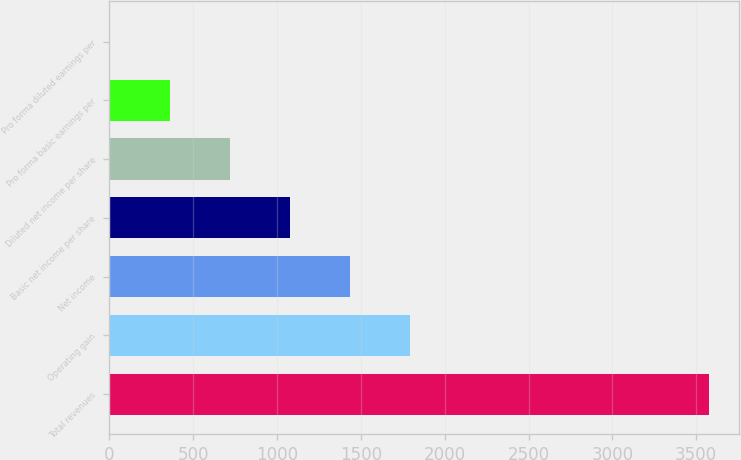Convert chart to OTSL. <chart><loc_0><loc_0><loc_500><loc_500><bar_chart><fcel>Total revenues<fcel>Operating gain<fcel>Net income<fcel>Basic net income per share<fcel>Diluted net income per share<fcel>Pro forma basic earnings per<fcel>Pro forma diluted earnings per<nl><fcel>3579.4<fcel>1790.22<fcel>1432.39<fcel>1074.56<fcel>716.73<fcel>358.9<fcel>1.07<nl></chart> 